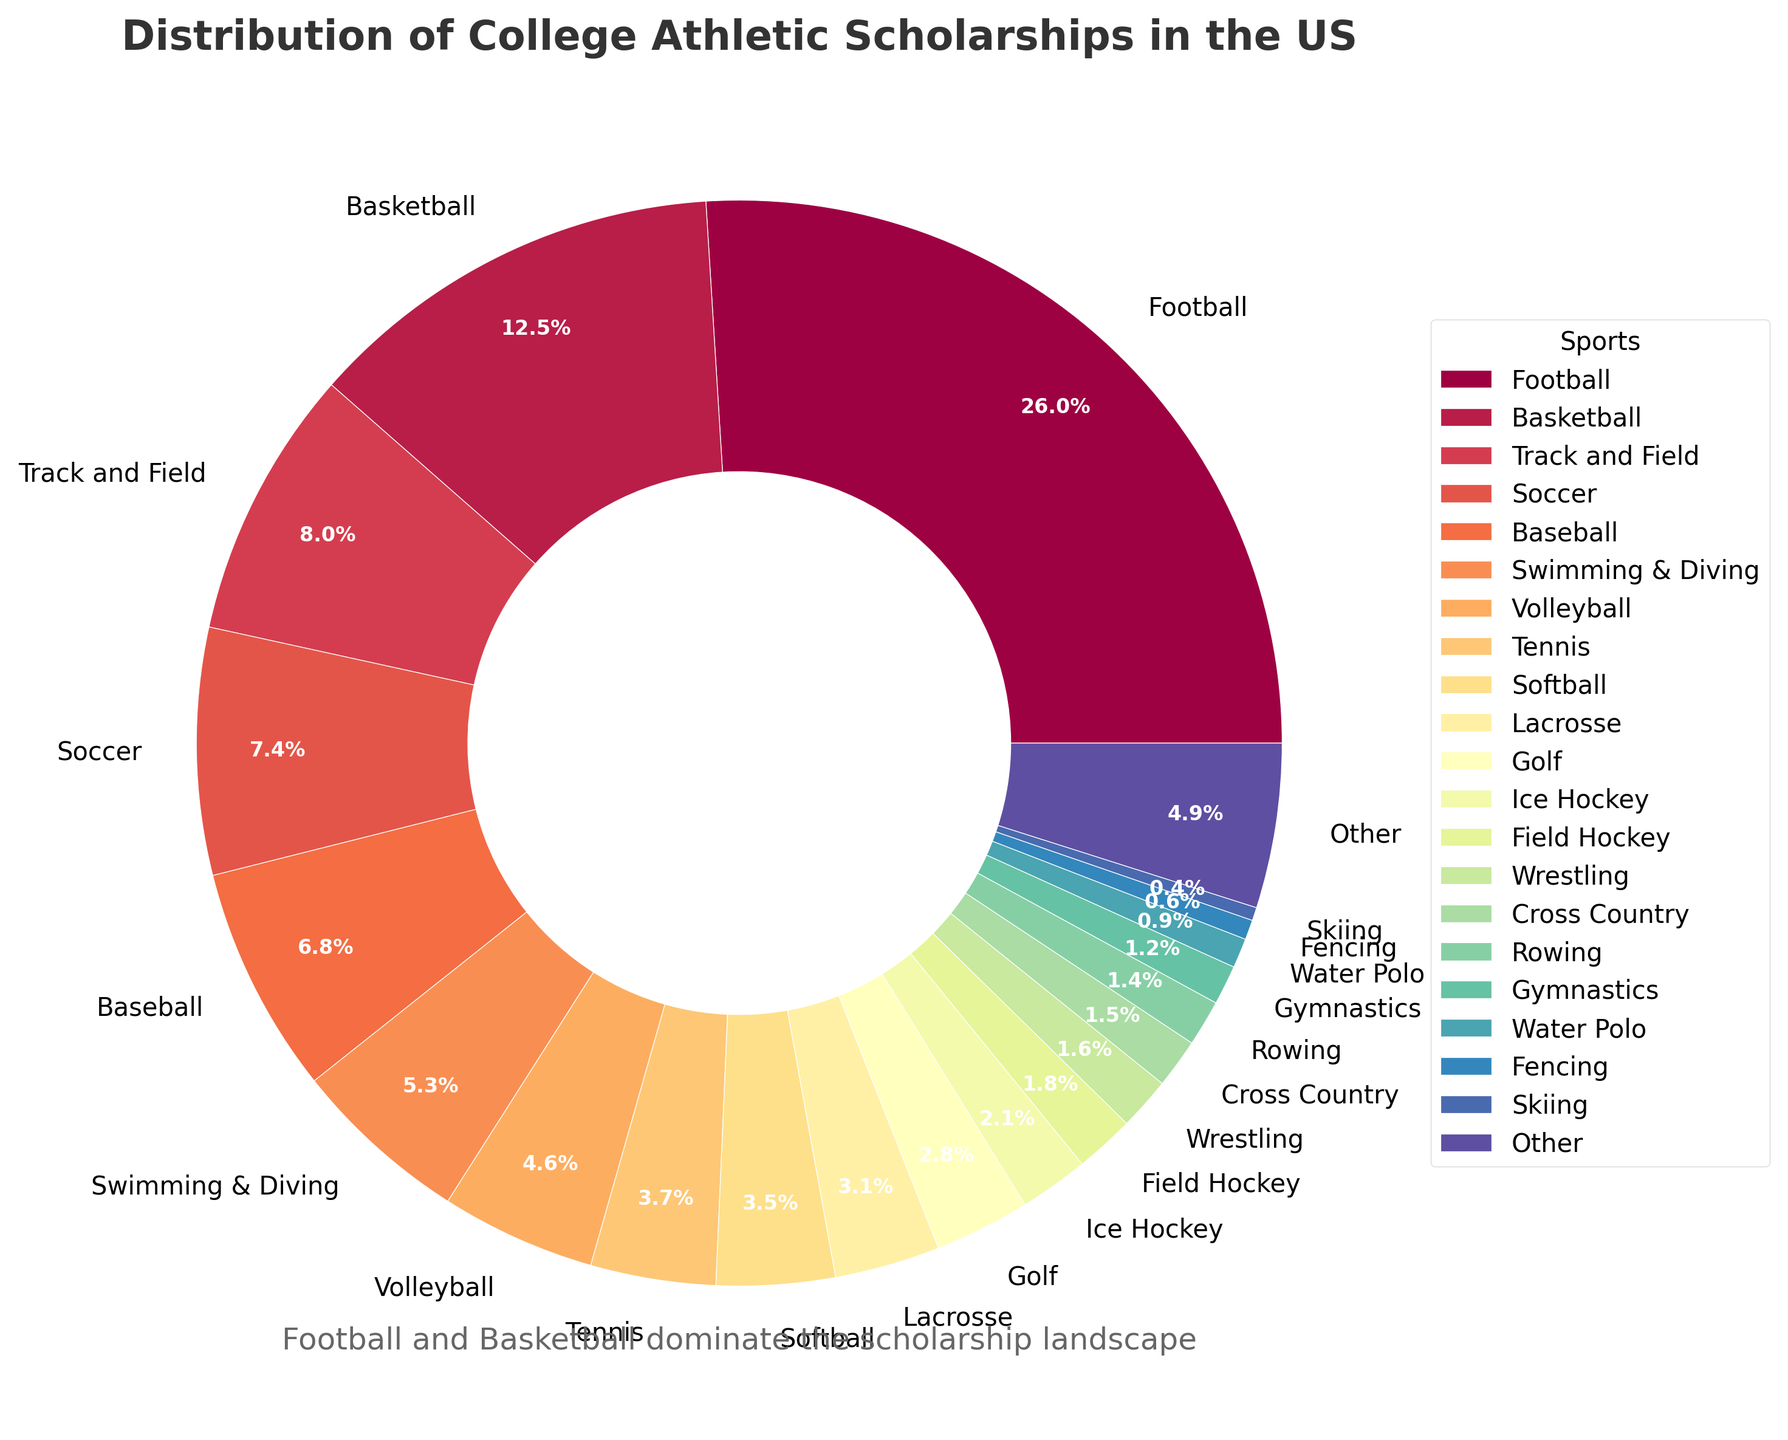Which sport receives the highest percentage of college athletic scholarships? Look at the pie chart and identify which sport has the largest segment. The sport with the largest segment is Football.
Answer: Football What is the combined percentage of scholarships given to Basketball and Soccer? First, find the percentage of scholarships given to Basketball and Soccer from the chart, which are 12.8% and 7.5% respectively. Then, add these percentages together: 12.8 + 7.5 = 20.3%.
Answer: 20.3% How much more in percentage terms do Track and Field scholarships account for compared to Volleyball scholarships? Look at the pie chart to find the percentages for Track and Field and Volleyball, which are 8.2% and 4.7%, respectively. Then, subtract the two percentages: 8.2 - 4.7 = 3.5%.
Answer: 3.5% Which two sports have nearly the same percentage of scholarships, according to the pie chart, and what are their exact percentages? Look for sports with similar-sized segments. Tennis and Softball have nearly the same percentages, 3.8% and 3.6%, respectively.
Answer: Tennis (3.8%) and Softball (3.6%) What is the total percentage of scholarships given to less popular sports (those listed with less than 2%)? Identify all sports with percentages less than 2%, sum them: Ice Hockey (2.1% is not included), Field Hockey (1.8%), Wrestling (1.6%), Cross Country (1.5%), Rowing (1.4%), Gymnastics (1.2%), Water Polo (0.9%), Fencing (0.6%), Skiing (0.4%). 1.8 + 1.6 + 1.5 + 1.4 + 1.2 + 0.9 + 0.6 + 0.4 = 9.4%.
Answer: 9.4% Which sport has a larger scholarship percentage, Baseball or Swimming & Diving, and by how much? Look at the pie chart to find the percentages for Baseball and Swimming & Diving, which are 6.9% and 5.4%, respectively. Subtract the smaller percentage from the larger one: 6.9 - 5.4 = 1.5%.
Answer: Baseball by 1.5% What is the percentage difference between the scholarships given to Lacrosse and Golf? Identify the segments for Lacrosse and Golf from the pie chart, which are 3.2% and 2.9% respectively. Then, subtract the two percentages: 3.2 - 2.9 = 0.3%.
Answer: 0.3% How do the scholarships for Football compare to the combined scholarships for Golf and Tennis? Find the percentages for Football, Golf, and Tennis; they are 26.5%, 2.9%, and 3.8%, respectively. Add the percentages for Golf and Tennis: 2.9 + 3.8 = 6.7%. Compare this to the percentage for Football: 26.5% vs. 6.7%. Football has a much higher percentage.
Answer: Football is much higher Which sport just surpasses 5% in scholarships awarded? Look at the pie chart and find the sport segment that is just over 5%. Swimming & Diving, with a percentage of 5.4%, slightly surpasses 5%.
Answer: Swimming & Diving 